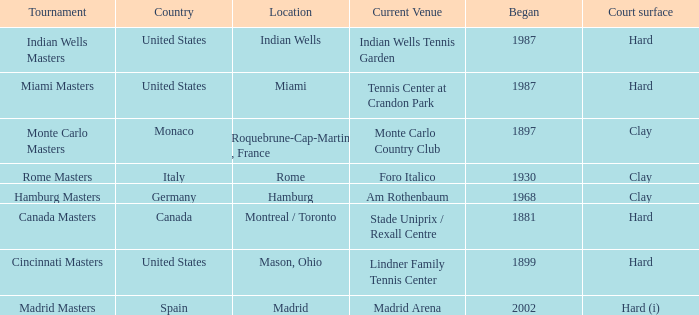What is the existing place for the miami masters tournament? Tennis Center at Crandon Park. 